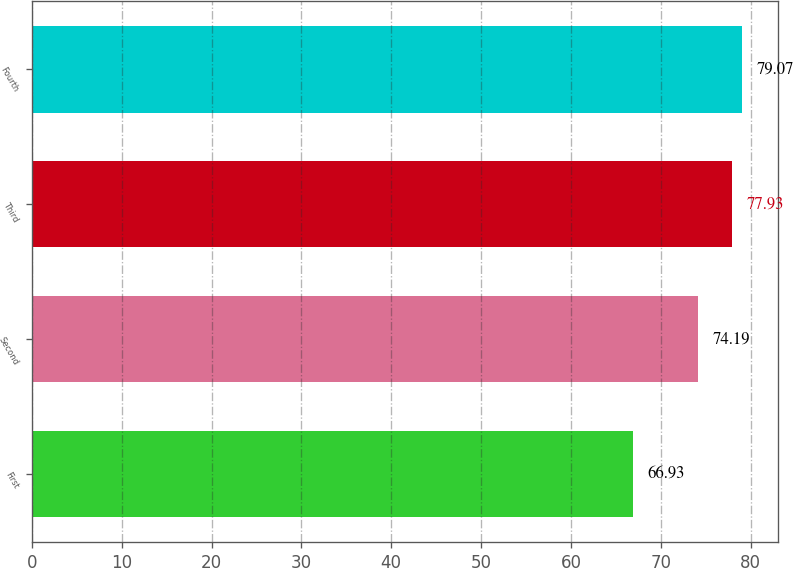Convert chart. <chart><loc_0><loc_0><loc_500><loc_500><bar_chart><fcel>First<fcel>Second<fcel>Third<fcel>Fourth<nl><fcel>66.93<fcel>74.19<fcel>77.93<fcel>79.07<nl></chart> 